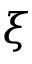<formula> <loc_0><loc_0><loc_500><loc_500>\xi</formula> 